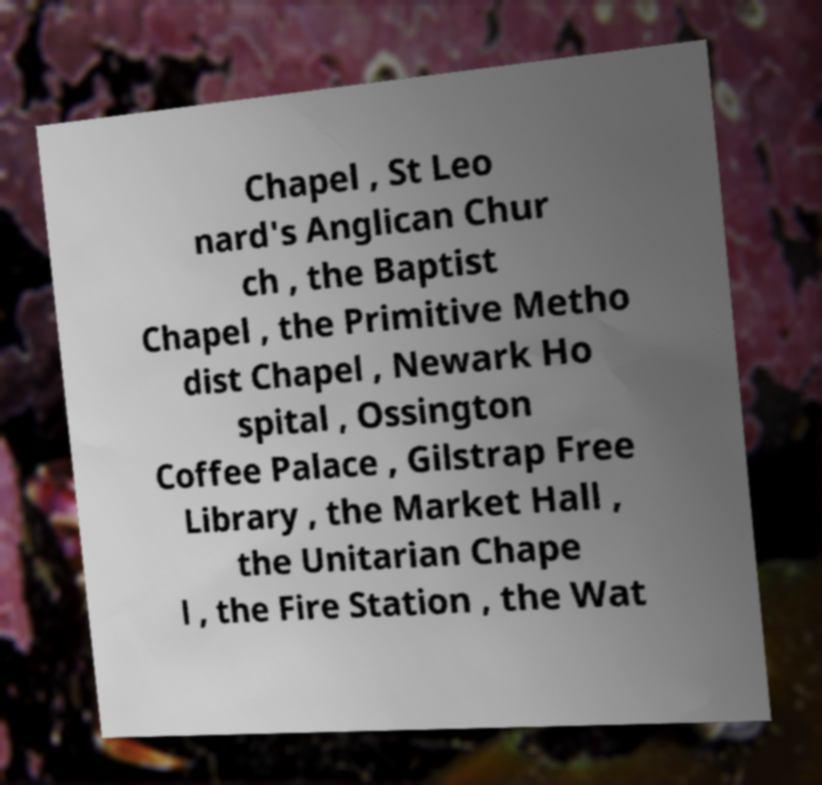For documentation purposes, I need the text within this image transcribed. Could you provide that? Chapel , St Leo nard's Anglican Chur ch , the Baptist Chapel , the Primitive Metho dist Chapel , Newark Ho spital , Ossington Coffee Palace , Gilstrap Free Library , the Market Hall , the Unitarian Chape l , the Fire Station , the Wat 